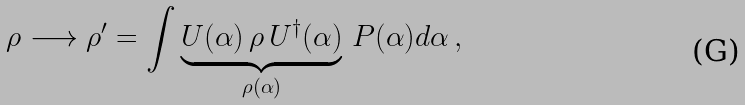<formula> <loc_0><loc_0><loc_500><loc_500>\rho \longrightarrow \rho ^ { \prime } = \int \underbrace { U ( \alpha ) \, \rho \, U ^ { \dag } ( \alpha ) } _ { \rho ( \alpha ) } \, P ( \alpha ) d \alpha \, ,</formula> 